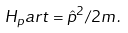<formula> <loc_0><loc_0><loc_500><loc_500>H _ { p } a r t = \hat { p } ^ { 2 } / 2 m \, .</formula> 